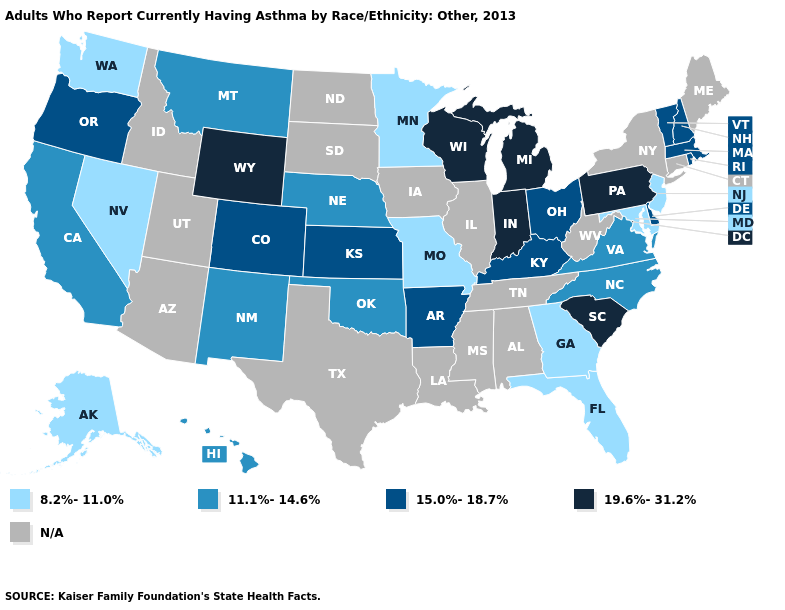Does the map have missing data?
Answer briefly. Yes. Name the states that have a value in the range 15.0%-18.7%?
Keep it brief. Arkansas, Colorado, Delaware, Kansas, Kentucky, Massachusetts, New Hampshire, Ohio, Oregon, Rhode Island, Vermont. What is the value of New York?
Short answer required. N/A. Which states have the highest value in the USA?
Write a very short answer. Indiana, Michigan, Pennsylvania, South Carolina, Wisconsin, Wyoming. What is the value of Georgia?
Quick response, please. 8.2%-11.0%. Name the states that have a value in the range 19.6%-31.2%?
Quick response, please. Indiana, Michigan, Pennsylvania, South Carolina, Wisconsin, Wyoming. Does South Carolina have the highest value in the USA?
Keep it brief. Yes. What is the lowest value in the West?
Be succinct. 8.2%-11.0%. Which states have the lowest value in the MidWest?
Answer briefly. Minnesota, Missouri. Name the states that have a value in the range 15.0%-18.7%?
Write a very short answer. Arkansas, Colorado, Delaware, Kansas, Kentucky, Massachusetts, New Hampshire, Ohio, Oregon, Rhode Island, Vermont. What is the lowest value in states that border Michigan?
Keep it brief. 15.0%-18.7%. Among the states that border Kansas , which have the highest value?
Quick response, please. Colorado. Name the states that have a value in the range 19.6%-31.2%?
Answer briefly. Indiana, Michigan, Pennsylvania, South Carolina, Wisconsin, Wyoming. What is the value of Connecticut?
Give a very brief answer. N/A. 